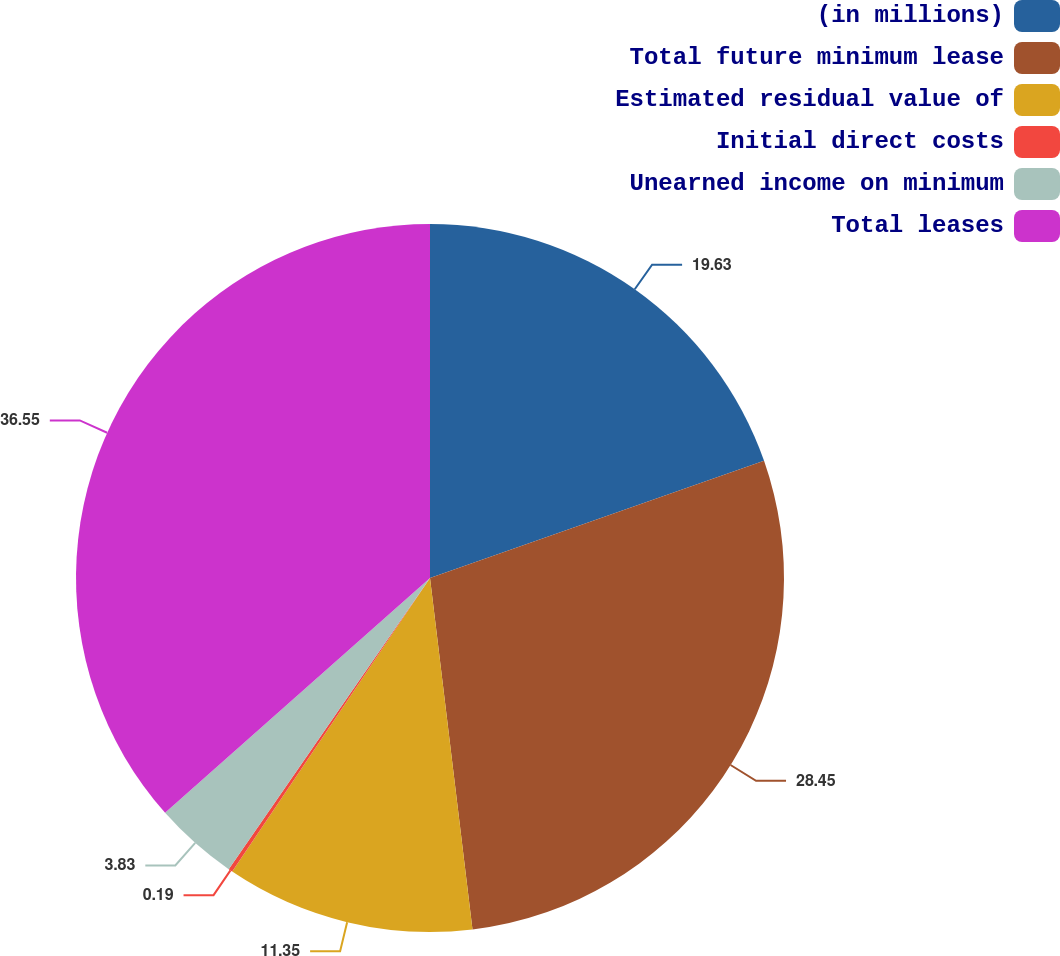Convert chart. <chart><loc_0><loc_0><loc_500><loc_500><pie_chart><fcel>(in millions)<fcel>Total future minimum lease<fcel>Estimated residual value of<fcel>Initial direct costs<fcel>Unearned income on minimum<fcel>Total leases<nl><fcel>19.63%<fcel>28.45%<fcel>11.35%<fcel>0.19%<fcel>3.83%<fcel>36.54%<nl></chart> 